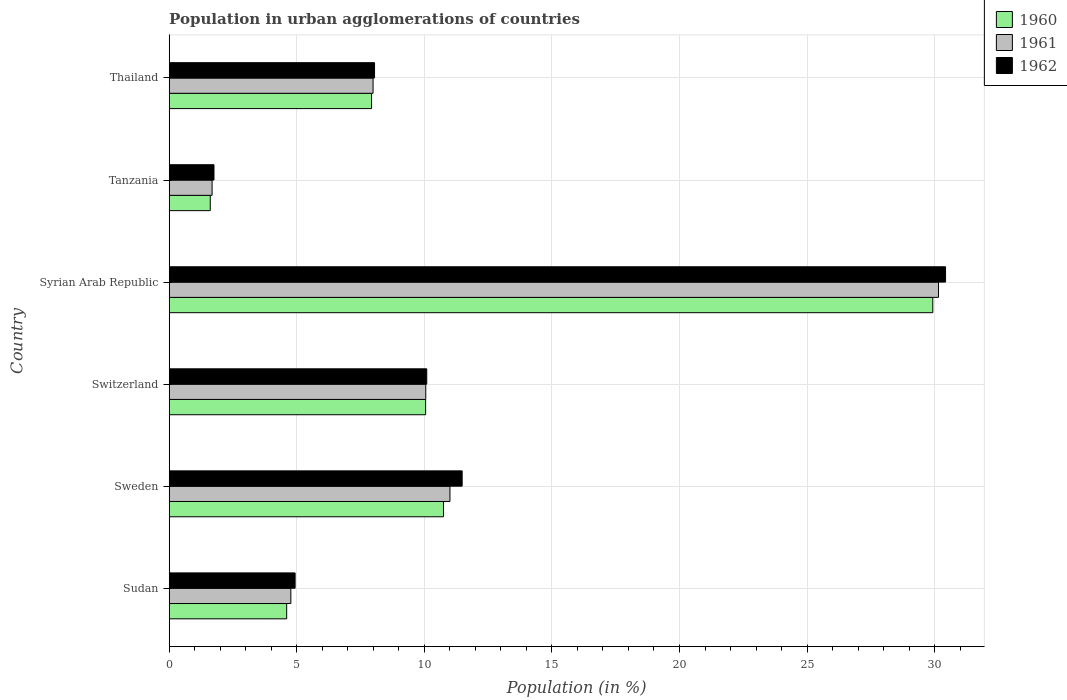How many different coloured bars are there?
Make the answer very short. 3. How many groups of bars are there?
Provide a succinct answer. 6. Are the number of bars per tick equal to the number of legend labels?
Make the answer very short. Yes. How many bars are there on the 6th tick from the top?
Provide a short and direct response. 3. How many bars are there on the 5th tick from the bottom?
Give a very brief answer. 3. What is the label of the 2nd group of bars from the top?
Offer a very short reply. Tanzania. In how many cases, is the number of bars for a given country not equal to the number of legend labels?
Provide a short and direct response. 0. What is the percentage of population in urban agglomerations in 1962 in Switzerland?
Ensure brevity in your answer.  10.09. Across all countries, what is the maximum percentage of population in urban agglomerations in 1962?
Give a very brief answer. 30.43. Across all countries, what is the minimum percentage of population in urban agglomerations in 1960?
Your response must be concise. 1.61. In which country was the percentage of population in urban agglomerations in 1962 maximum?
Make the answer very short. Syrian Arab Republic. In which country was the percentage of population in urban agglomerations in 1962 minimum?
Provide a short and direct response. Tanzania. What is the total percentage of population in urban agglomerations in 1960 in the graph?
Offer a terse response. 64.87. What is the difference between the percentage of population in urban agglomerations in 1960 in Switzerland and that in Thailand?
Provide a short and direct response. 2.12. What is the difference between the percentage of population in urban agglomerations in 1962 in Switzerland and the percentage of population in urban agglomerations in 1961 in Sweden?
Keep it short and to the point. -0.91. What is the average percentage of population in urban agglomerations in 1962 per country?
Your response must be concise. 11.12. What is the difference between the percentage of population in urban agglomerations in 1960 and percentage of population in urban agglomerations in 1962 in Thailand?
Provide a succinct answer. -0.12. What is the ratio of the percentage of population in urban agglomerations in 1961 in Syrian Arab Republic to that in Thailand?
Ensure brevity in your answer.  3.77. Is the percentage of population in urban agglomerations in 1961 in Syrian Arab Republic less than that in Tanzania?
Ensure brevity in your answer.  No. Is the difference between the percentage of population in urban agglomerations in 1960 in Sweden and Thailand greater than the difference between the percentage of population in urban agglomerations in 1962 in Sweden and Thailand?
Your answer should be compact. No. What is the difference between the highest and the second highest percentage of population in urban agglomerations in 1962?
Ensure brevity in your answer.  18.95. What is the difference between the highest and the lowest percentage of population in urban agglomerations in 1962?
Give a very brief answer. 28.67. In how many countries, is the percentage of population in urban agglomerations in 1961 greater than the average percentage of population in urban agglomerations in 1961 taken over all countries?
Ensure brevity in your answer.  2. Is the sum of the percentage of population in urban agglomerations in 1960 in Switzerland and Syrian Arab Republic greater than the maximum percentage of population in urban agglomerations in 1962 across all countries?
Your answer should be compact. Yes. What does the 3rd bar from the bottom in Switzerland represents?
Make the answer very short. 1962. How many bars are there?
Offer a terse response. 18. Are all the bars in the graph horizontal?
Offer a very short reply. Yes. Does the graph contain any zero values?
Give a very brief answer. No. How many legend labels are there?
Your answer should be compact. 3. What is the title of the graph?
Your answer should be compact. Population in urban agglomerations of countries. Does "2012" appear as one of the legend labels in the graph?
Ensure brevity in your answer.  No. What is the label or title of the Y-axis?
Your answer should be very brief. Country. What is the Population (in %) in 1960 in Sudan?
Your answer should be very brief. 4.6. What is the Population (in %) of 1961 in Sudan?
Your response must be concise. 4.77. What is the Population (in %) of 1962 in Sudan?
Offer a very short reply. 4.93. What is the Population (in %) of 1960 in Sweden?
Your response must be concise. 10.75. What is the Population (in %) of 1961 in Sweden?
Keep it short and to the point. 11. What is the Population (in %) of 1962 in Sweden?
Provide a short and direct response. 11.48. What is the Population (in %) of 1960 in Switzerland?
Your response must be concise. 10.05. What is the Population (in %) of 1961 in Switzerland?
Your response must be concise. 10.06. What is the Population (in %) in 1962 in Switzerland?
Your answer should be very brief. 10.09. What is the Population (in %) in 1960 in Syrian Arab Republic?
Ensure brevity in your answer.  29.93. What is the Population (in %) of 1961 in Syrian Arab Republic?
Offer a very short reply. 30.15. What is the Population (in %) of 1962 in Syrian Arab Republic?
Ensure brevity in your answer.  30.43. What is the Population (in %) in 1960 in Tanzania?
Offer a terse response. 1.61. What is the Population (in %) in 1961 in Tanzania?
Give a very brief answer. 1.68. What is the Population (in %) in 1962 in Tanzania?
Provide a short and direct response. 1.76. What is the Population (in %) in 1960 in Thailand?
Your answer should be very brief. 7.93. What is the Population (in %) in 1961 in Thailand?
Offer a very short reply. 7.99. What is the Population (in %) in 1962 in Thailand?
Offer a terse response. 8.05. Across all countries, what is the maximum Population (in %) in 1960?
Your answer should be very brief. 29.93. Across all countries, what is the maximum Population (in %) in 1961?
Offer a very short reply. 30.15. Across all countries, what is the maximum Population (in %) in 1962?
Your answer should be very brief. 30.43. Across all countries, what is the minimum Population (in %) in 1960?
Your answer should be compact. 1.61. Across all countries, what is the minimum Population (in %) in 1961?
Your answer should be very brief. 1.68. Across all countries, what is the minimum Population (in %) in 1962?
Offer a terse response. 1.76. What is the total Population (in %) of 1960 in the graph?
Keep it short and to the point. 64.87. What is the total Population (in %) of 1961 in the graph?
Your answer should be compact. 65.65. What is the total Population (in %) of 1962 in the graph?
Provide a short and direct response. 66.74. What is the difference between the Population (in %) of 1960 in Sudan and that in Sweden?
Offer a terse response. -6.15. What is the difference between the Population (in %) in 1961 in Sudan and that in Sweden?
Offer a very short reply. -6.24. What is the difference between the Population (in %) of 1962 in Sudan and that in Sweden?
Provide a short and direct response. -6.55. What is the difference between the Population (in %) in 1960 in Sudan and that in Switzerland?
Your answer should be compact. -5.45. What is the difference between the Population (in %) of 1961 in Sudan and that in Switzerland?
Ensure brevity in your answer.  -5.29. What is the difference between the Population (in %) of 1962 in Sudan and that in Switzerland?
Your answer should be compact. -5.16. What is the difference between the Population (in %) in 1960 in Sudan and that in Syrian Arab Republic?
Your answer should be very brief. -25.32. What is the difference between the Population (in %) in 1961 in Sudan and that in Syrian Arab Republic?
Ensure brevity in your answer.  -25.38. What is the difference between the Population (in %) in 1962 in Sudan and that in Syrian Arab Republic?
Ensure brevity in your answer.  -25.49. What is the difference between the Population (in %) of 1960 in Sudan and that in Tanzania?
Your response must be concise. 3. What is the difference between the Population (in %) in 1961 in Sudan and that in Tanzania?
Offer a terse response. 3.09. What is the difference between the Population (in %) in 1962 in Sudan and that in Tanzania?
Ensure brevity in your answer.  3.18. What is the difference between the Population (in %) in 1960 in Sudan and that in Thailand?
Your answer should be very brief. -3.33. What is the difference between the Population (in %) of 1961 in Sudan and that in Thailand?
Offer a terse response. -3.22. What is the difference between the Population (in %) in 1962 in Sudan and that in Thailand?
Offer a terse response. -3.11. What is the difference between the Population (in %) in 1960 in Sweden and that in Switzerland?
Your answer should be compact. 0.7. What is the difference between the Population (in %) of 1961 in Sweden and that in Switzerland?
Ensure brevity in your answer.  0.95. What is the difference between the Population (in %) in 1962 in Sweden and that in Switzerland?
Your answer should be compact. 1.39. What is the difference between the Population (in %) in 1960 in Sweden and that in Syrian Arab Republic?
Your answer should be compact. -19.18. What is the difference between the Population (in %) in 1961 in Sweden and that in Syrian Arab Republic?
Your answer should be very brief. -19.15. What is the difference between the Population (in %) in 1962 in Sweden and that in Syrian Arab Republic?
Offer a very short reply. -18.95. What is the difference between the Population (in %) in 1960 in Sweden and that in Tanzania?
Ensure brevity in your answer.  9.14. What is the difference between the Population (in %) in 1961 in Sweden and that in Tanzania?
Provide a succinct answer. 9.32. What is the difference between the Population (in %) of 1962 in Sweden and that in Tanzania?
Your answer should be compact. 9.73. What is the difference between the Population (in %) in 1960 in Sweden and that in Thailand?
Your answer should be very brief. 2.82. What is the difference between the Population (in %) of 1961 in Sweden and that in Thailand?
Provide a short and direct response. 3.01. What is the difference between the Population (in %) in 1962 in Sweden and that in Thailand?
Your answer should be very brief. 3.43. What is the difference between the Population (in %) in 1960 in Switzerland and that in Syrian Arab Republic?
Provide a short and direct response. -19.88. What is the difference between the Population (in %) in 1961 in Switzerland and that in Syrian Arab Republic?
Ensure brevity in your answer.  -20.1. What is the difference between the Population (in %) in 1962 in Switzerland and that in Syrian Arab Republic?
Ensure brevity in your answer.  -20.33. What is the difference between the Population (in %) in 1960 in Switzerland and that in Tanzania?
Provide a succinct answer. 8.44. What is the difference between the Population (in %) in 1961 in Switzerland and that in Tanzania?
Your answer should be very brief. 8.38. What is the difference between the Population (in %) in 1962 in Switzerland and that in Tanzania?
Give a very brief answer. 8.34. What is the difference between the Population (in %) of 1960 in Switzerland and that in Thailand?
Offer a terse response. 2.12. What is the difference between the Population (in %) of 1961 in Switzerland and that in Thailand?
Give a very brief answer. 2.07. What is the difference between the Population (in %) of 1962 in Switzerland and that in Thailand?
Provide a succinct answer. 2.05. What is the difference between the Population (in %) of 1960 in Syrian Arab Republic and that in Tanzania?
Offer a very short reply. 28.32. What is the difference between the Population (in %) in 1961 in Syrian Arab Republic and that in Tanzania?
Keep it short and to the point. 28.47. What is the difference between the Population (in %) of 1962 in Syrian Arab Republic and that in Tanzania?
Your answer should be compact. 28.67. What is the difference between the Population (in %) in 1960 in Syrian Arab Republic and that in Thailand?
Your answer should be compact. 22. What is the difference between the Population (in %) in 1961 in Syrian Arab Republic and that in Thailand?
Provide a succinct answer. 22.16. What is the difference between the Population (in %) of 1962 in Syrian Arab Republic and that in Thailand?
Give a very brief answer. 22.38. What is the difference between the Population (in %) of 1960 in Tanzania and that in Thailand?
Make the answer very short. -6.32. What is the difference between the Population (in %) of 1961 in Tanzania and that in Thailand?
Provide a succinct answer. -6.31. What is the difference between the Population (in %) in 1962 in Tanzania and that in Thailand?
Offer a very short reply. -6.29. What is the difference between the Population (in %) in 1960 in Sudan and the Population (in %) in 1961 in Sweden?
Ensure brevity in your answer.  -6.4. What is the difference between the Population (in %) of 1960 in Sudan and the Population (in %) of 1962 in Sweden?
Your answer should be very brief. -6.88. What is the difference between the Population (in %) of 1961 in Sudan and the Population (in %) of 1962 in Sweden?
Provide a succinct answer. -6.71. What is the difference between the Population (in %) of 1960 in Sudan and the Population (in %) of 1961 in Switzerland?
Your response must be concise. -5.45. What is the difference between the Population (in %) of 1960 in Sudan and the Population (in %) of 1962 in Switzerland?
Keep it short and to the point. -5.49. What is the difference between the Population (in %) in 1961 in Sudan and the Population (in %) in 1962 in Switzerland?
Give a very brief answer. -5.33. What is the difference between the Population (in %) in 1960 in Sudan and the Population (in %) in 1961 in Syrian Arab Republic?
Give a very brief answer. -25.55. What is the difference between the Population (in %) in 1960 in Sudan and the Population (in %) in 1962 in Syrian Arab Republic?
Your response must be concise. -25.82. What is the difference between the Population (in %) of 1961 in Sudan and the Population (in %) of 1962 in Syrian Arab Republic?
Your answer should be compact. -25.66. What is the difference between the Population (in %) of 1960 in Sudan and the Population (in %) of 1961 in Tanzania?
Keep it short and to the point. 2.92. What is the difference between the Population (in %) of 1960 in Sudan and the Population (in %) of 1962 in Tanzania?
Keep it short and to the point. 2.85. What is the difference between the Population (in %) in 1961 in Sudan and the Population (in %) in 1962 in Tanzania?
Offer a very short reply. 3.01. What is the difference between the Population (in %) in 1960 in Sudan and the Population (in %) in 1961 in Thailand?
Ensure brevity in your answer.  -3.39. What is the difference between the Population (in %) in 1960 in Sudan and the Population (in %) in 1962 in Thailand?
Give a very brief answer. -3.44. What is the difference between the Population (in %) in 1961 in Sudan and the Population (in %) in 1962 in Thailand?
Provide a succinct answer. -3.28. What is the difference between the Population (in %) of 1960 in Sweden and the Population (in %) of 1961 in Switzerland?
Offer a very short reply. 0.69. What is the difference between the Population (in %) of 1960 in Sweden and the Population (in %) of 1962 in Switzerland?
Your answer should be compact. 0.66. What is the difference between the Population (in %) in 1961 in Sweden and the Population (in %) in 1962 in Switzerland?
Your answer should be compact. 0.91. What is the difference between the Population (in %) of 1960 in Sweden and the Population (in %) of 1961 in Syrian Arab Republic?
Give a very brief answer. -19.4. What is the difference between the Population (in %) of 1960 in Sweden and the Population (in %) of 1962 in Syrian Arab Republic?
Provide a short and direct response. -19.68. What is the difference between the Population (in %) of 1961 in Sweden and the Population (in %) of 1962 in Syrian Arab Republic?
Ensure brevity in your answer.  -19.42. What is the difference between the Population (in %) of 1960 in Sweden and the Population (in %) of 1961 in Tanzania?
Give a very brief answer. 9.07. What is the difference between the Population (in %) of 1960 in Sweden and the Population (in %) of 1962 in Tanzania?
Your answer should be very brief. 8.99. What is the difference between the Population (in %) of 1961 in Sweden and the Population (in %) of 1962 in Tanzania?
Ensure brevity in your answer.  9.25. What is the difference between the Population (in %) of 1960 in Sweden and the Population (in %) of 1961 in Thailand?
Keep it short and to the point. 2.76. What is the difference between the Population (in %) of 1960 in Sweden and the Population (in %) of 1962 in Thailand?
Provide a succinct answer. 2.7. What is the difference between the Population (in %) in 1961 in Sweden and the Population (in %) in 1962 in Thailand?
Provide a succinct answer. 2.96. What is the difference between the Population (in %) of 1960 in Switzerland and the Population (in %) of 1961 in Syrian Arab Republic?
Give a very brief answer. -20.1. What is the difference between the Population (in %) of 1960 in Switzerland and the Population (in %) of 1962 in Syrian Arab Republic?
Your response must be concise. -20.38. What is the difference between the Population (in %) of 1961 in Switzerland and the Population (in %) of 1962 in Syrian Arab Republic?
Ensure brevity in your answer.  -20.37. What is the difference between the Population (in %) of 1960 in Switzerland and the Population (in %) of 1961 in Tanzania?
Make the answer very short. 8.37. What is the difference between the Population (in %) in 1960 in Switzerland and the Population (in %) in 1962 in Tanzania?
Keep it short and to the point. 8.3. What is the difference between the Population (in %) of 1961 in Switzerland and the Population (in %) of 1962 in Tanzania?
Keep it short and to the point. 8.3. What is the difference between the Population (in %) in 1960 in Switzerland and the Population (in %) in 1961 in Thailand?
Your answer should be compact. 2.06. What is the difference between the Population (in %) in 1960 in Switzerland and the Population (in %) in 1962 in Thailand?
Your response must be concise. 2. What is the difference between the Population (in %) of 1961 in Switzerland and the Population (in %) of 1962 in Thailand?
Offer a very short reply. 2.01. What is the difference between the Population (in %) in 1960 in Syrian Arab Republic and the Population (in %) in 1961 in Tanzania?
Provide a short and direct response. 28.25. What is the difference between the Population (in %) of 1960 in Syrian Arab Republic and the Population (in %) of 1962 in Tanzania?
Provide a succinct answer. 28.17. What is the difference between the Population (in %) of 1961 in Syrian Arab Republic and the Population (in %) of 1962 in Tanzania?
Your answer should be very brief. 28.4. What is the difference between the Population (in %) of 1960 in Syrian Arab Republic and the Population (in %) of 1961 in Thailand?
Your answer should be very brief. 21.94. What is the difference between the Population (in %) of 1960 in Syrian Arab Republic and the Population (in %) of 1962 in Thailand?
Provide a short and direct response. 21.88. What is the difference between the Population (in %) in 1961 in Syrian Arab Republic and the Population (in %) in 1962 in Thailand?
Provide a short and direct response. 22.1. What is the difference between the Population (in %) in 1960 in Tanzania and the Population (in %) in 1961 in Thailand?
Provide a succinct answer. -6.38. What is the difference between the Population (in %) of 1960 in Tanzania and the Population (in %) of 1962 in Thailand?
Provide a succinct answer. -6.44. What is the difference between the Population (in %) in 1961 in Tanzania and the Population (in %) in 1962 in Thailand?
Your response must be concise. -6.37. What is the average Population (in %) of 1960 per country?
Offer a terse response. 10.81. What is the average Population (in %) in 1961 per country?
Your response must be concise. 10.94. What is the average Population (in %) in 1962 per country?
Offer a very short reply. 11.12. What is the difference between the Population (in %) in 1960 and Population (in %) in 1961 in Sudan?
Your answer should be compact. -0.16. What is the difference between the Population (in %) of 1960 and Population (in %) of 1962 in Sudan?
Make the answer very short. -0.33. What is the difference between the Population (in %) of 1961 and Population (in %) of 1962 in Sudan?
Offer a very short reply. -0.17. What is the difference between the Population (in %) of 1960 and Population (in %) of 1961 in Sweden?
Provide a succinct answer. -0.25. What is the difference between the Population (in %) in 1960 and Population (in %) in 1962 in Sweden?
Your answer should be very brief. -0.73. What is the difference between the Population (in %) in 1961 and Population (in %) in 1962 in Sweden?
Offer a terse response. -0.48. What is the difference between the Population (in %) of 1960 and Population (in %) of 1961 in Switzerland?
Ensure brevity in your answer.  -0.01. What is the difference between the Population (in %) in 1960 and Population (in %) in 1962 in Switzerland?
Your answer should be compact. -0.04. What is the difference between the Population (in %) in 1961 and Population (in %) in 1962 in Switzerland?
Provide a succinct answer. -0.04. What is the difference between the Population (in %) in 1960 and Population (in %) in 1961 in Syrian Arab Republic?
Offer a very short reply. -0.22. What is the difference between the Population (in %) in 1960 and Population (in %) in 1962 in Syrian Arab Republic?
Your response must be concise. -0.5. What is the difference between the Population (in %) in 1961 and Population (in %) in 1962 in Syrian Arab Republic?
Provide a succinct answer. -0.28. What is the difference between the Population (in %) in 1960 and Population (in %) in 1961 in Tanzania?
Your response must be concise. -0.07. What is the difference between the Population (in %) in 1960 and Population (in %) in 1962 in Tanzania?
Offer a very short reply. -0.15. What is the difference between the Population (in %) in 1961 and Population (in %) in 1962 in Tanzania?
Your answer should be very brief. -0.07. What is the difference between the Population (in %) of 1960 and Population (in %) of 1961 in Thailand?
Your answer should be very brief. -0.06. What is the difference between the Population (in %) of 1960 and Population (in %) of 1962 in Thailand?
Offer a terse response. -0.12. What is the difference between the Population (in %) in 1961 and Population (in %) in 1962 in Thailand?
Keep it short and to the point. -0.06. What is the ratio of the Population (in %) of 1960 in Sudan to that in Sweden?
Keep it short and to the point. 0.43. What is the ratio of the Population (in %) of 1961 in Sudan to that in Sweden?
Provide a succinct answer. 0.43. What is the ratio of the Population (in %) in 1962 in Sudan to that in Sweden?
Your answer should be compact. 0.43. What is the ratio of the Population (in %) of 1960 in Sudan to that in Switzerland?
Make the answer very short. 0.46. What is the ratio of the Population (in %) of 1961 in Sudan to that in Switzerland?
Your response must be concise. 0.47. What is the ratio of the Population (in %) of 1962 in Sudan to that in Switzerland?
Your answer should be compact. 0.49. What is the ratio of the Population (in %) of 1960 in Sudan to that in Syrian Arab Republic?
Provide a short and direct response. 0.15. What is the ratio of the Population (in %) of 1961 in Sudan to that in Syrian Arab Republic?
Offer a very short reply. 0.16. What is the ratio of the Population (in %) in 1962 in Sudan to that in Syrian Arab Republic?
Keep it short and to the point. 0.16. What is the ratio of the Population (in %) in 1960 in Sudan to that in Tanzania?
Give a very brief answer. 2.86. What is the ratio of the Population (in %) in 1961 in Sudan to that in Tanzania?
Provide a short and direct response. 2.84. What is the ratio of the Population (in %) of 1962 in Sudan to that in Tanzania?
Make the answer very short. 2.81. What is the ratio of the Population (in %) of 1960 in Sudan to that in Thailand?
Provide a short and direct response. 0.58. What is the ratio of the Population (in %) of 1961 in Sudan to that in Thailand?
Your answer should be very brief. 0.6. What is the ratio of the Population (in %) in 1962 in Sudan to that in Thailand?
Keep it short and to the point. 0.61. What is the ratio of the Population (in %) of 1960 in Sweden to that in Switzerland?
Your response must be concise. 1.07. What is the ratio of the Population (in %) of 1961 in Sweden to that in Switzerland?
Make the answer very short. 1.09. What is the ratio of the Population (in %) of 1962 in Sweden to that in Switzerland?
Offer a very short reply. 1.14. What is the ratio of the Population (in %) of 1960 in Sweden to that in Syrian Arab Republic?
Provide a short and direct response. 0.36. What is the ratio of the Population (in %) in 1961 in Sweden to that in Syrian Arab Republic?
Ensure brevity in your answer.  0.36. What is the ratio of the Population (in %) in 1962 in Sweden to that in Syrian Arab Republic?
Your answer should be very brief. 0.38. What is the ratio of the Population (in %) in 1960 in Sweden to that in Tanzania?
Give a very brief answer. 6.68. What is the ratio of the Population (in %) in 1961 in Sweden to that in Tanzania?
Your response must be concise. 6.55. What is the ratio of the Population (in %) of 1962 in Sweden to that in Tanzania?
Ensure brevity in your answer.  6.54. What is the ratio of the Population (in %) of 1960 in Sweden to that in Thailand?
Ensure brevity in your answer.  1.36. What is the ratio of the Population (in %) in 1961 in Sweden to that in Thailand?
Give a very brief answer. 1.38. What is the ratio of the Population (in %) of 1962 in Sweden to that in Thailand?
Offer a terse response. 1.43. What is the ratio of the Population (in %) in 1960 in Switzerland to that in Syrian Arab Republic?
Ensure brevity in your answer.  0.34. What is the ratio of the Population (in %) of 1961 in Switzerland to that in Syrian Arab Republic?
Make the answer very short. 0.33. What is the ratio of the Population (in %) of 1962 in Switzerland to that in Syrian Arab Republic?
Give a very brief answer. 0.33. What is the ratio of the Population (in %) of 1960 in Switzerland to that in Tanzania?
Provide a short and direct response. 6.25. What is the ratio of the Population (in %) of 1961 in Switzerland to that in Tanzania?
Your answer should be very brief. 5.98. What is the ratio of the Population (in %) in 1962 in Switzerland to that in Tanzania?
Your answer should be very brief. 5.75. What is the ratio of the Population (in %) in 1960 in Switzerland to that in Thailand?
Provide a succinct answer. 1.27. What is the ratio of the Population (in %) in 1961 in Switzerland to that in Thailand?
Offer a terse response. 1.26. What is the ratio of the Population (in %) in 1962 in Switzerland to that in Thailand?
Provide a short and direct response. 1.25. What is the ratio of the Population (in %) of 1960 in Syrian Arab Republic to that in Tanzania?
Ensure brevity in your answer.  18.6. What is the ratio of the Population (in %) in 1961 in Syrian Arab Republic to that in Tanzania?
Your response must be concise. 17.94. What is the ratio of the Population (in %) of 1962 in Syrian Arab Republic to that in Tanzania?
Make the answer very short. 17.34. What is the ratio of the Population (in %) of 1960 in Syrian Arab Republic to that in Thailand?
Make the answer very short. 3.77. What is the ratio of the Population (in %) in 1961 in Syrian Arab Republic to that in Thailand?
Ensure brevity in your answer.  3.77. What is the ratio of the Population (in %) of 1962 in Syrian Arab Republic to that in Thailand?
Give a very brief answer. 3.78. What is the ratio of the Population (in %) in 1960 in Tanzania to that in Thailand?
Your answer should be very brief. 0.2. What is the ratio of the Population (in %) of 1961 in Tanzania to that in Thailand?
Make the answer very short. 0.21. What is the ratio of the Population (in %) of 1962 in Tanzania to that in Thailand?
Provide a short and direct response. 0.22. What is the difference between the highest and the second highest Population (in %) of 1960?
Your response must be concise. 19.18. What is the difference between the highest and the second highest Population (in %) in 1961?
Your answer should be compact. 19.15. What is the difference between the highest and the second highest Population (in %) in 1962?
Your answer should be very brief. 18.95. What is the difference between the highest and the lowest Population (in %) of 1960?
Provide a succinct answer. 28.32. What is the difference between the highest and the lowest Population (in %) in 1961?
Your response must be concise. 28.47. What is the difference between the highest and the lowest Population (in %) in 1962?
Offer a terse response. 28.67. 